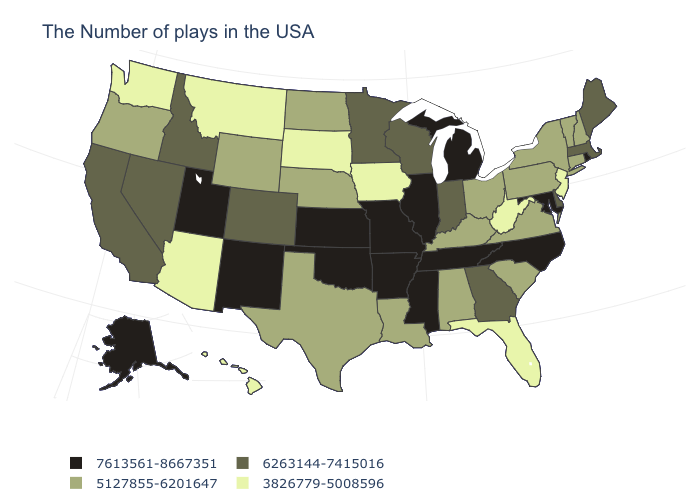What is the highest value in states that border Maine?
Quick response, please. 5127855-6201647. Is the legend a continuous bar?
Concise answer only. No. What is the lowest value in states that border Indiana?
Short answer required. 5127855-6201647. Does the first symbol in the legend represent the smallest category?
Write a very short answer. No. What is the value of Washington?
Answer briefly. 3826779-5008596. What is the value of Montana?
Be succinct. 3826779-5008596. What is the value of California?
Write a very short answer. 6263144-7415016. What is the highest value in states that border Maine?
Short answer required. 5127855-6201647. What is the lowest value in the USA?
Answer briefly. 3826779-5008596. What is the value of Arkansas?
Give a very brief answer. 7613561-8667351. What is the value of New Hampshire?
Keep it brief. 5127855-6201647. Is the legend a continuous bar?
Write a very short answer. No. Among the states that border Kansas , which have the lowest value?
Write a very short answer. Nebraska. Does Mississippi have the same value as Idaho?
Answer briefly. No. Does the first symbol in the legend represent the smallest category?
Short answer required. No. 